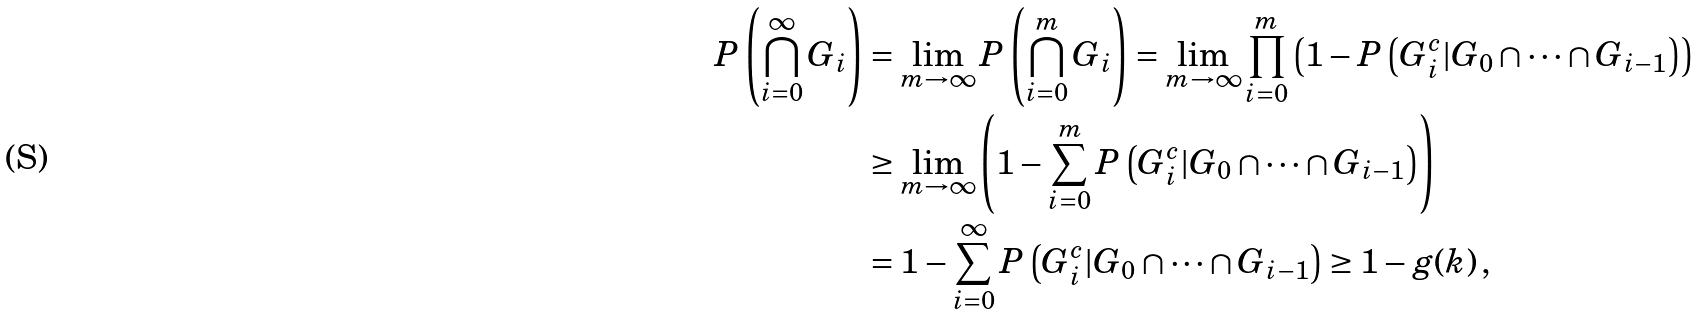<formula> <loc_0><loc_0><loc_500><loc_500>P \left ( \bigcap _ { i = 0 } ^ { \infty } G _ { i } \right ) & = \lim _ { m \to \infty } P \left ( \bigcap _ { i = 0 } ^ { m } G _ { i } \right ) = \lim _ { m \to \infty } \prod _ { i = 0 } ^ { m } \left ( 1 - P \left ( G _ { i } ^ { c } | G _ { 0 } \cap \dots \cap G _ { i - 1 } \right ) \right ) \\ & \geq \lim _ { m \to \infty } \left ( 1 - \sum _ { i = 0 } ^ { m } P \left ( G _ { i } ^ { c } | G _ { 0 } \cap \dots \cap G _ { i - 1 } \right ) \right ) \\ & = 1 - \sum _ { i = 0 } ^ { \infty } P \left ( G _ { i } ^ { c } | G _ { 0 } \cap \dots \cap G _ { i - 1 } \right ) \geq 1 - g ( k ) \, ,</formula> 